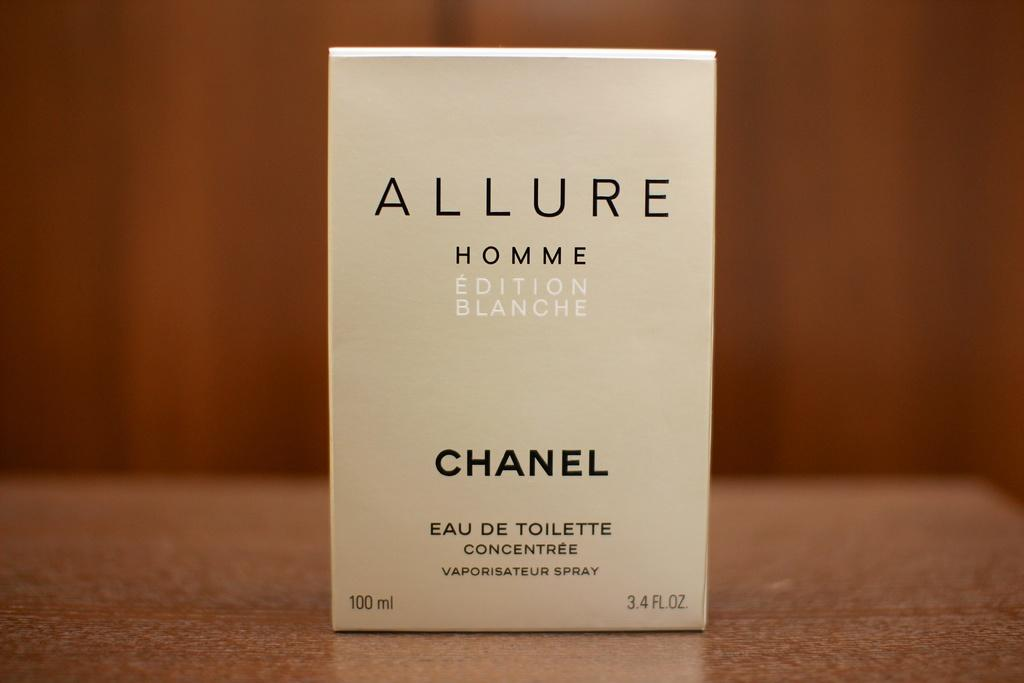<image>
Create a compact narrative representing the image presented. Allure Homme Eau de Toilette is a product of Chanel. 